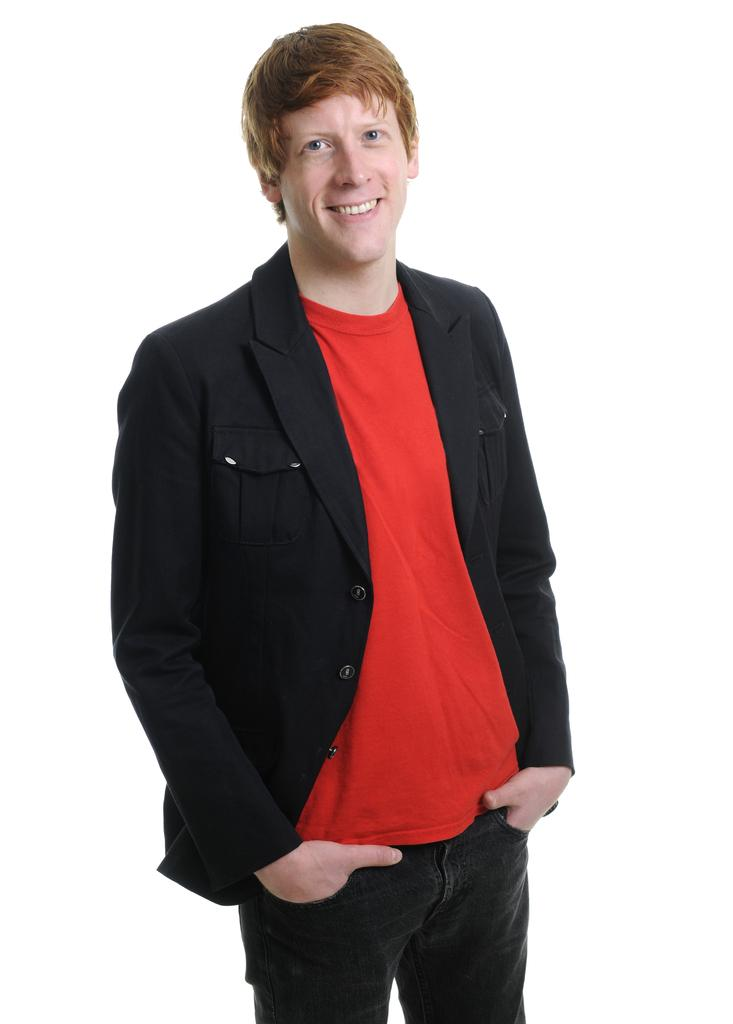What is the main subject of the image? The main subject of the image is a man. What is the man doing in the image? The man is standing in the image. What is the man's facial expression in the image? The man is smiling in the image. What type of glass is the man holding in the image? There is no glass present in the image; the man is not holding anything. 